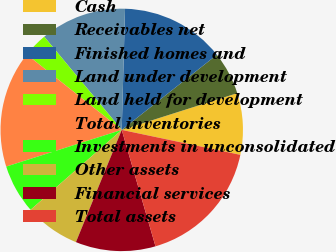Convert chart. <chart><loc_0><loc_0><loc_500><loc_500><pie_chart><fcel>Cash<fcel>Receivables net<fcel>Finished homes and<fcel>Land under development<fcel>Land held for development<fcel>Total inventories<fcel>Investments in unconsolidated<fcel>Other assets<fcel>Financial services<fcel>Total assets<nl><fcel>8.2%<fcel>5.74%<fcel>13.93%<fcel>11.48%<fcel>3.28%<fcel>15.57%<fcel>6.56%<fcel>7.38%<fcel>10.66%<fcel>17.21%<nl></chart> 